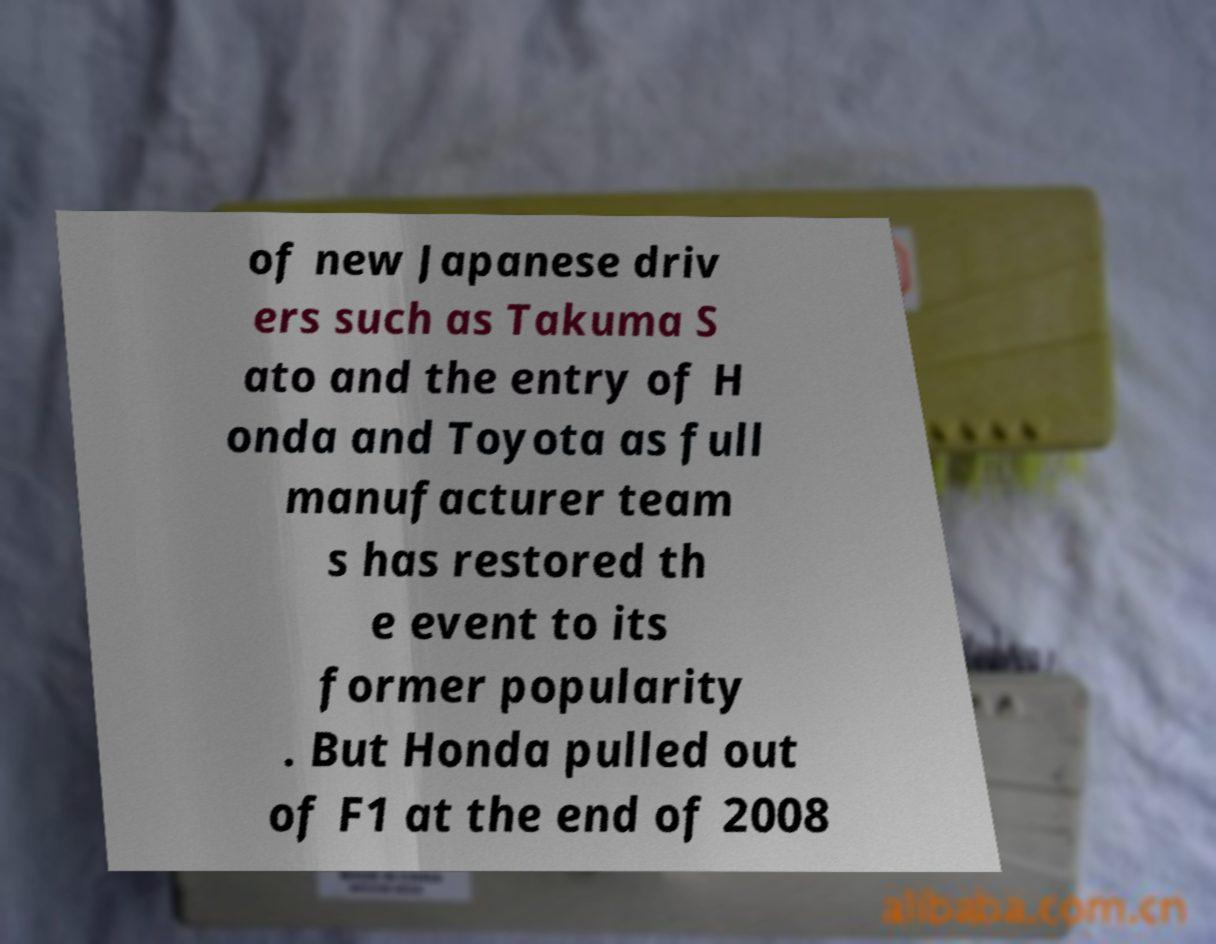There's text embedded in this image that I need extracted. Can you transcribe it verbatim? of new Japanese driv ers such as Takuma S ato and the entry of H onda and Toyota as full manufacturer team s has restored th e event to its former popularity . But Honda pulled out of F1 at the end of 2008 